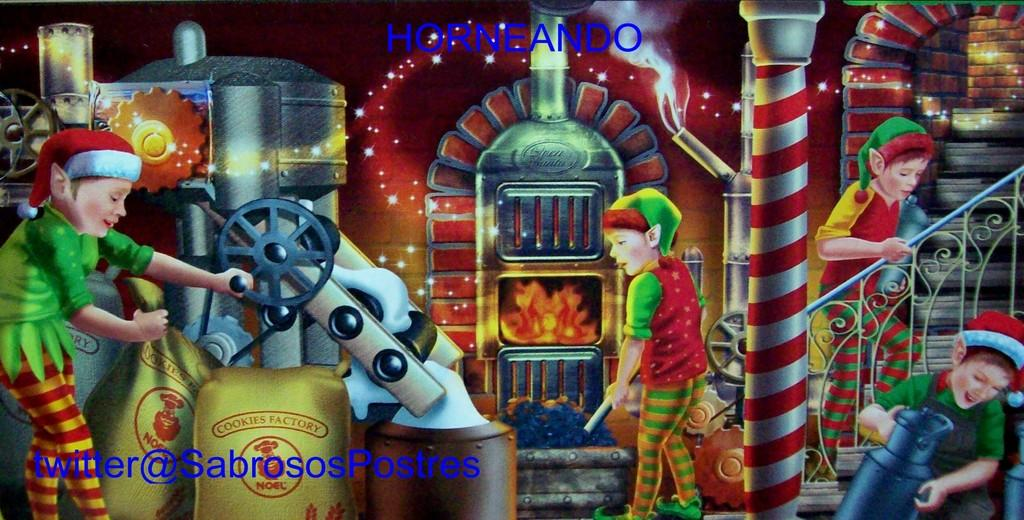What are the people in the image holding? The people in the image are holding something, but the facts do not specify what they are holding. What type of machine is present in the image? The facts do not specify the type of machine in the image. What are the bags in the image used for? The facts do not specify the purpose of the bags in the image. What are the poles used for in the image? The facts do not specify the purpose of the poles in the image. What are the stairs used for in the image? The facts do not specify the purpose of the stairs in the image. What colors are the objects mentioned in the image? The facts state that the objects mentioned are in different colors, but do not specify which colors. How many chickens are sitting on the furniture in the image? There are no chickens or furniture present in the image. 